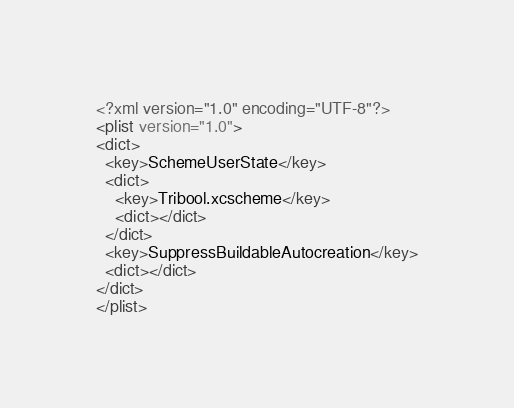<code> <loc_0><loc_0><loc_500><loc_500><_XML_><?xml version="1.0" encoding="UTF-8"?>
<plist version="1.0">
<dict>
  <key>SchemeUserState</key>
  <dict>
    <key>Tribool.xcscheme</key>
    <dict></dict>
  </dict>
  <key>SuppressBuildableAutocreation</key>
  <dict></dict>
</dict>
</plist>
</code> 